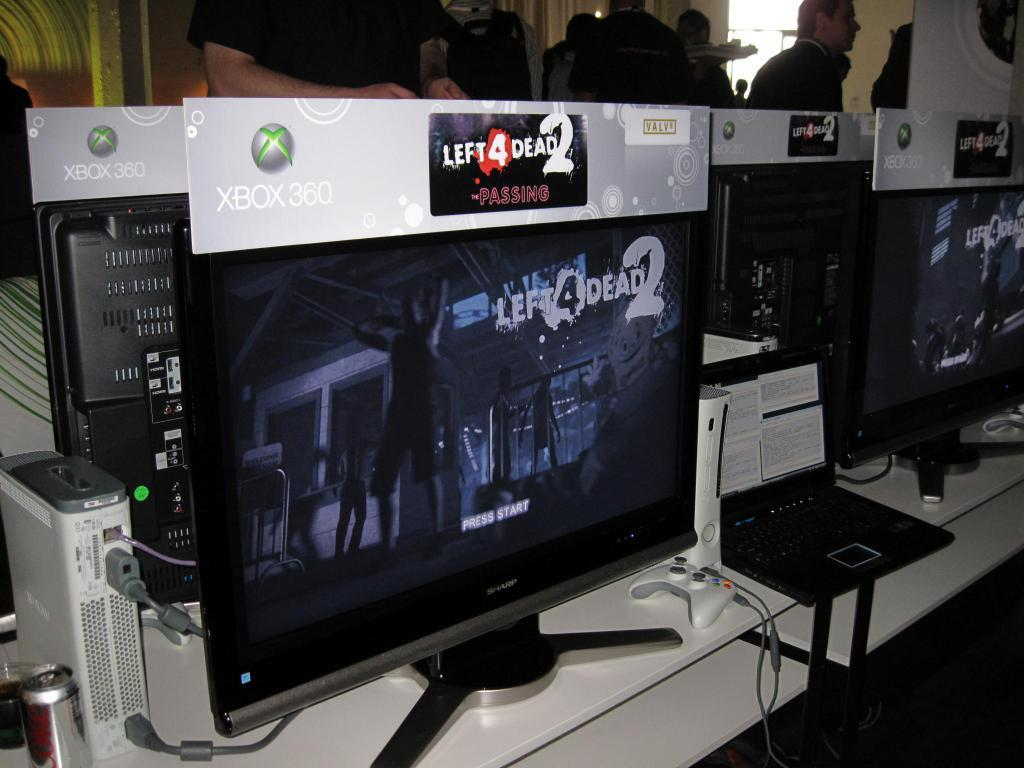<image>
Render a clear and concise summary of the photo. several monitors are set up with Left 4 Dead 2 advertised above them 